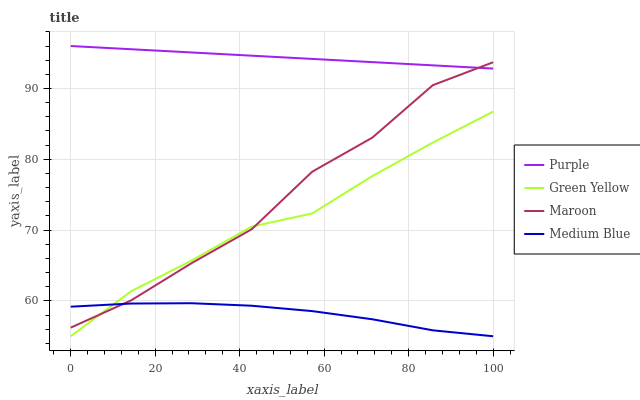Does Medium Blue have the minimum area under the curve?
Answer yes or no. Yes. Does Purple have the maximum area under the curve?
Answer yes or no. Yes. Does Green Yellow have the minimum area under the curve?
Answer yes or no. No. Does Green Yellow have the maximum area under the curve?
Answer yes or no. No. Is Purple the smoothest?
Answer yes or no. Yes. Is Maroon the roughest?
Answer yes or no. Yes. Is Green Yellow the smoothest?
Answer yes or no. No. Is Green Yellow the roughest?
Answer yes or no. No. Does Maroon have the lowest value?
Answer yes or no. No. Does Purple have the highest value?
Answer yes or no. Yes. Does Green Yellow have the highest value?
Answer yes or no. No. Is Green Yellow less than Purple?
Answer yes or no. Yes. Is Purple greater than Medium Blue?
Answer yes or no. Yes. Does Green Yellow intersect Maroon?
Answer yes or no. Yes. Is Green Yellow less than Maroon?
Answer yes or no. No. Is Green Yellow greater than Maroon?
Answer yes or no. No. Does Green Yellow intersect Purple?
Answer yes or no. No. 